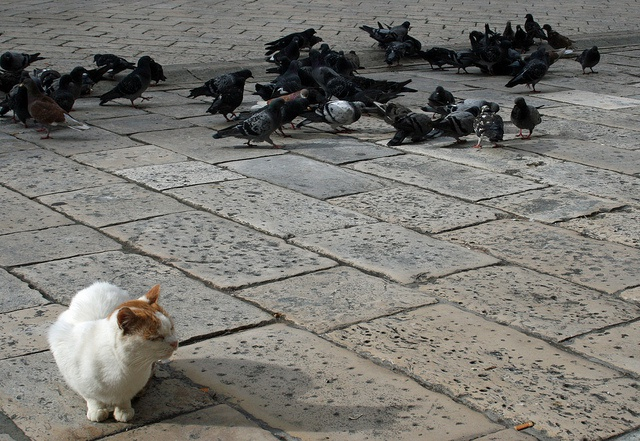Describe the objects in this image and their specific colors. I can see bird in gray and black tones, cat in gray, lightgray, darkgray, and maroon tones, bird in gray, black, and purple tones, bird in gray, black, and darkgray tones, and bird in gray, black, darkgray, and purple tones in this image. 